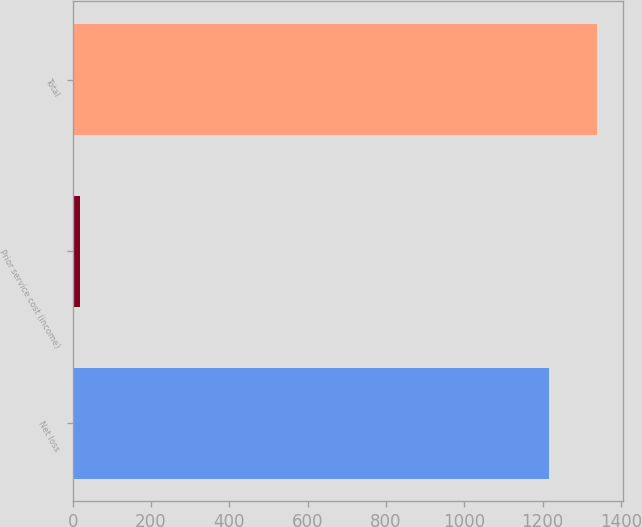<chart> <loc_0><loc_0><loc_500><loc_500><bar_chart><fcel>Net loss<fcel>Prior service cost (income)<fcel>Total<nl><fcel>1217<fcel>19<fcel>1338.7<nl></chart> 